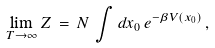Convert formula to latex. <formula><loc_0><loc_0><loc_500><loc_500>\lim _ { T \rightarrow \infty } Z \, = \, N \, \int d x _ { 0 } \, e ^ { - \beta V ( x _ { 0 } ) } \, ,</formula> 